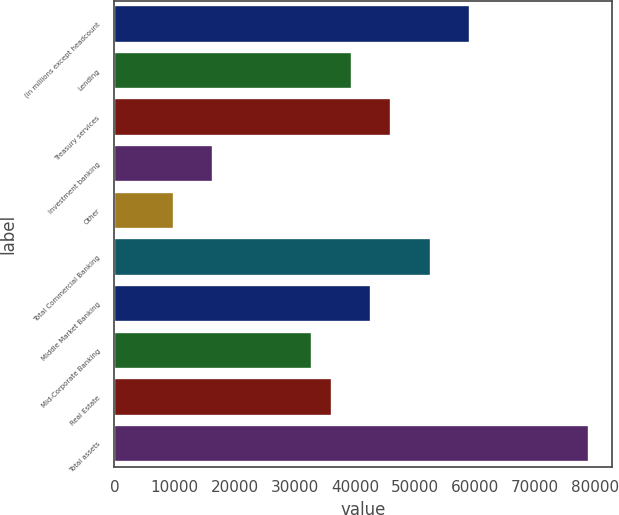<chart> <loc_0><loc_0><loc_500><loc_500><bar_chart><fcel>(in millions except headcount<fcel>Lending<fcel>Treasury services<fcel>Investment banking<fcel>Other<fcel>Total Commercial Banking<fcel>Middle Market Banking<fcel>Mid-Corporate Banking<fcel>Real Estate<fcel>Total assets<nl><fcel>59183.6<fcel>39455.9<fcel>46031.8<fcel>16440.3<fcel>9864.39<fcel>52607.7<fcel>42743.9<fcel>32880<fcel>36168<fcel>78911.3<nl></chart> 